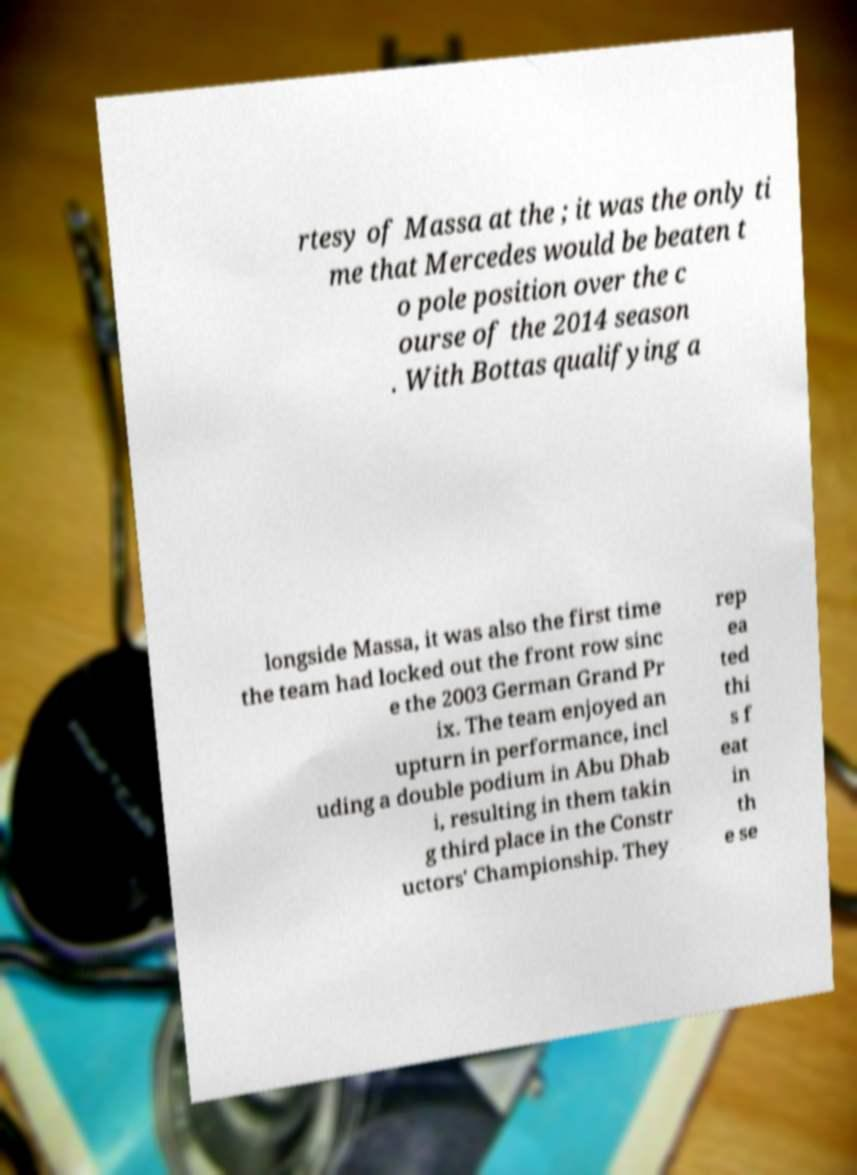Could you assist in decoding the text presented in this image and type it out clearly? rtesy of Massa at the ; it was the only ti me that Mercedes would be beaten t o pole position over the c ourse of the 2014 season . With Bottas qualifying a longside Massa, it was also the first time the team had locked out the front row sinc e the 2003 German Grand Pr ix. The team enjoyed an upturn in performance, incl uding a double podium in Abu Dhab i, resulting in them takin g third place in the Constr uctors' Championship. They rep ea ted thi s f eat in th e se 